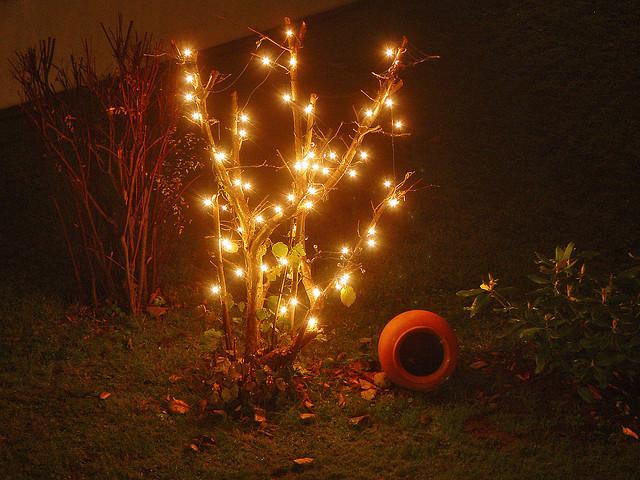How many lights are there?
Quick response, please. 50. What kind of plant are the light attached to?
Answer briefly. Bush. What energy supplies the lights?
Give a very brief answer. Electricity. 